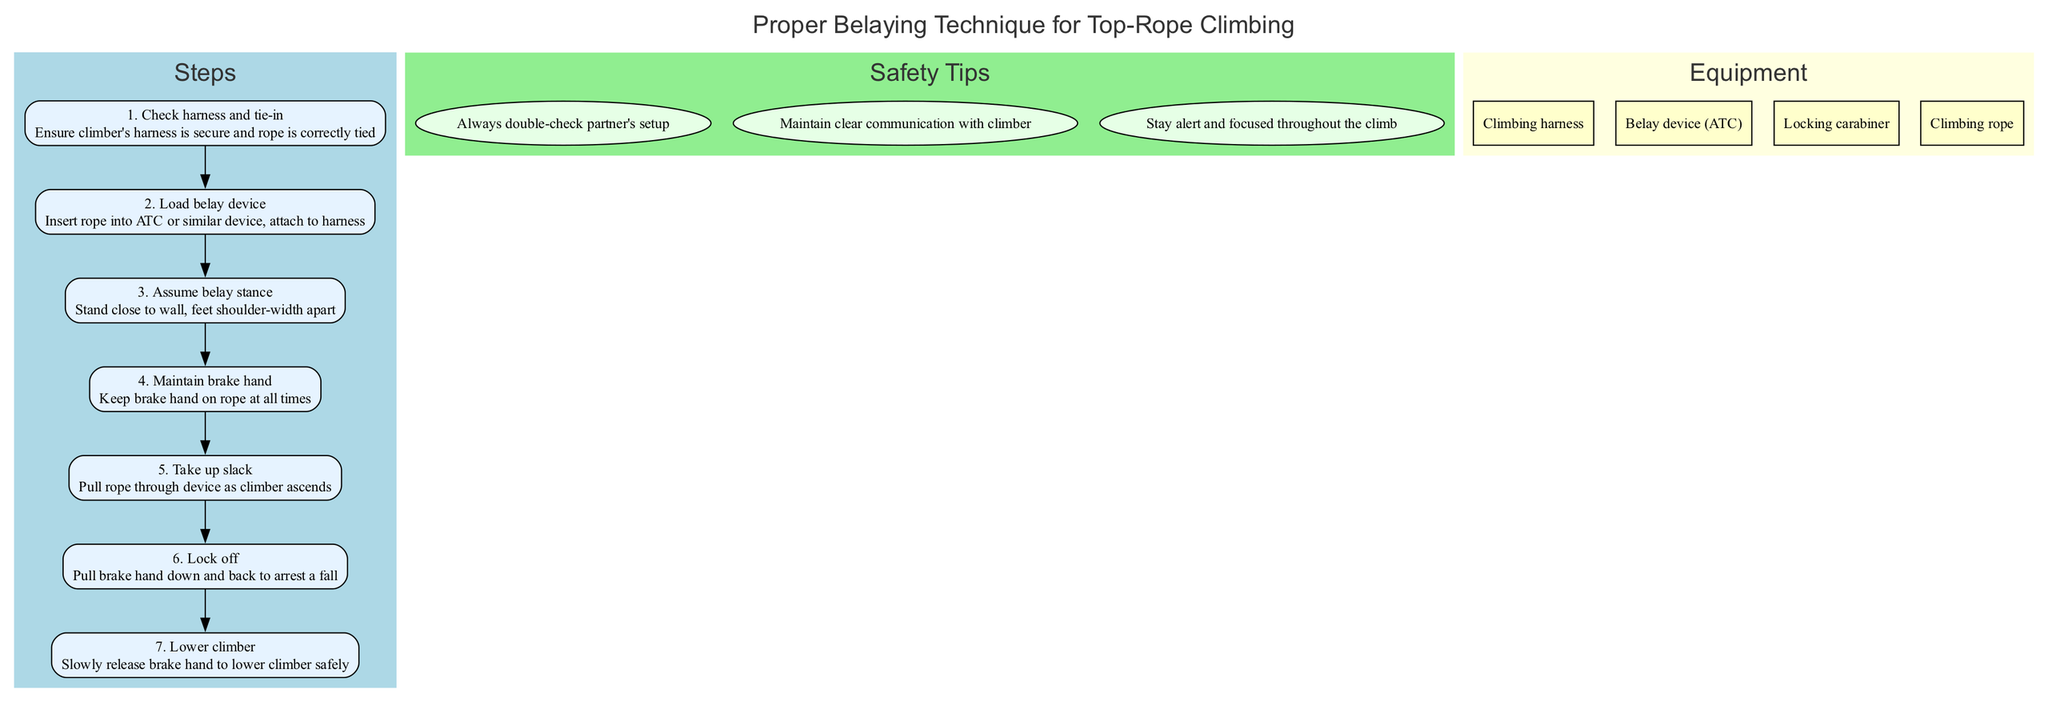What is the first step in the belaying technique? The first step listed in the diagram is "Check harness and tie-in." This indicates the initial action required before proceeding with the belaying process.
Answer: Check harness and tie-in How many safety tips are provided in the diagram? By counting the nodes in the safety tips section of the diagram, there are three tips mentioned, indicating the number of safety precautions to follow.
Answer: 3 What is the action of Step 5? The fifth step identified in the diagram is "Take up slack," which describes the action required when the climber ascends the rope.
Answer: Take up slack What equipment is used to secure the rope? The equipment needed to secure the rope includes a "Locking carabiner," which is essential for safely attaching the rope and ensuring secure belaying.
Answer: Locking carabiner What happens in Step 6? In the sixth step, "Lock off" is performed, which means the belayer pulls their brake hand down and back to effectively arrest a fall, highlighting a critical safety action.
Answer: Lock off Which step requires the belayer to stand close to the wall? Step 3 specifies that the belayer should "Assume belay stance," which involves standing close to the wall for better stability during the climbing process.
Answer: Assume belay stance What color is used for the equipment section in the diagram? The equipment section is filled with a light yellow color, consistent with the design style of the diagram to visually distinguish it from other sections.
Answer: Light yellow How is communication recommended to be maintained with the climber? The safety tips emphasize that "Maintain clear communication with climber," indicating the necessity for effective dialogue to ensure safety during climbing.
Answer: Maintain clear communication with climber What is the final action taken in the belaying process? The last step in the diagram is "Lower climber," which describes the final action a belayer takes to safely lower the climber after they have finished their ascent.
Answer: Lower climber 